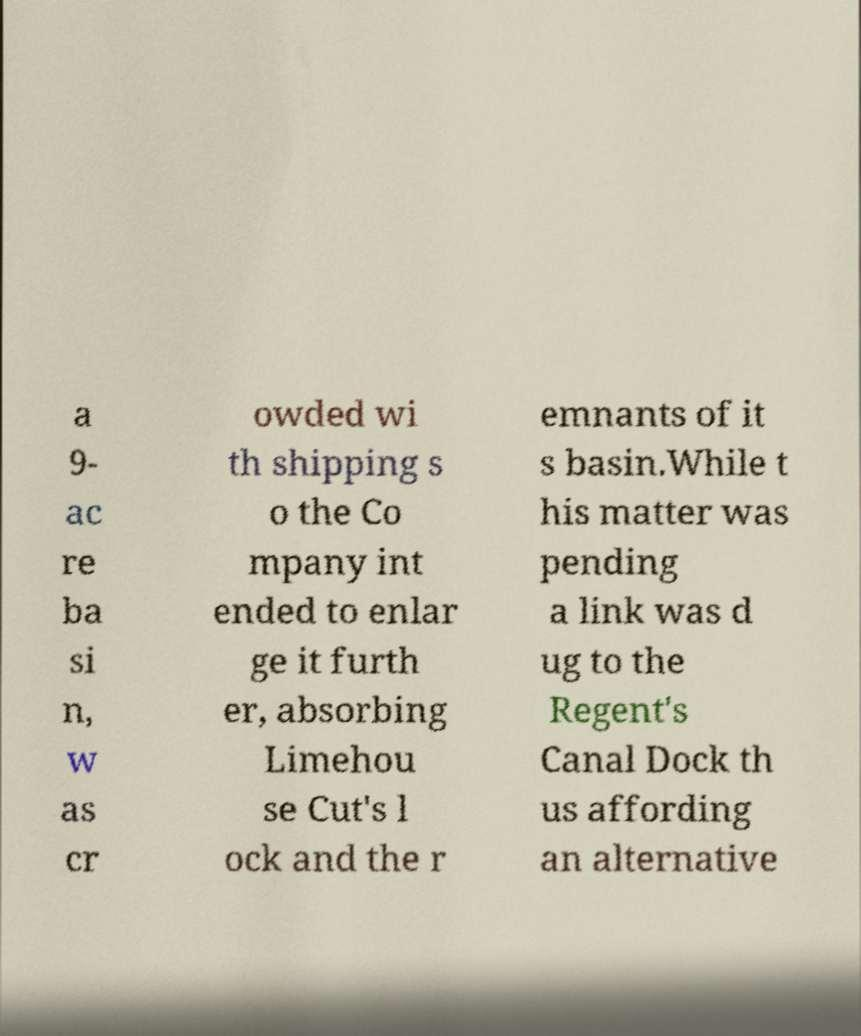Can you read and provide the text displayed in the image?This photo seems to have some interesting text. Can you extract and type it out for me? a 9- ac re ba si n, w as cr owded wi th shipping s o the Co mpany int ended to enlar ge it furth er, absorbing Limehou se Cut's l ock and the r emnants of it s basin.While t his matter was pending a link was d ug to the Regent's Canal Dock th us affording an alternative 